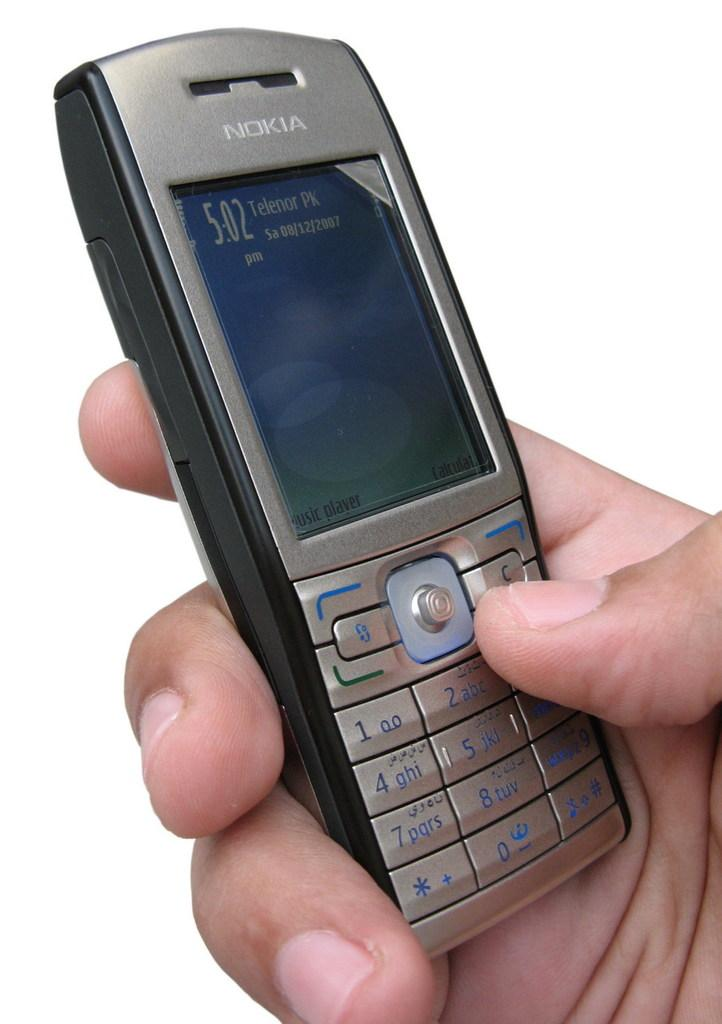What is the main subject in the center of the image? There is a person's hand and a mobile in the center of the image. Can you describe the mobile in the image? The mobile appears to be a small device with a screen, possibly a smartphone or tablet. How many yams are being held by the person in the image? There are no yams present in the image; only a person's hand and a mobile can be seen. What type of chickens are visible in the image? There are no chickens present in the image; only a person's hand and a mobile can be seen. 